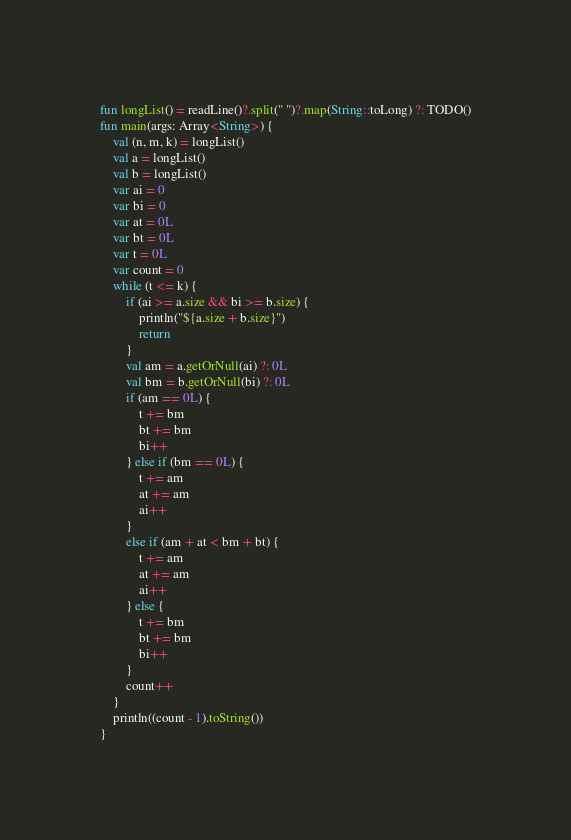Convert code to text. <code><loc_0><loc_0><loc_500><loc_500><_Kotlin_>fun longList() = readLine()?.split(" ")?.map(String::toLong) ?: TODO()
fun main(args: Array<String>) {
    val (n, m, k) = longList()
    val a = longList()
    val b = longList()
    var ai = 0
    var bi = 0
    var at = 0L
    var bt = 0L
    var t = 0L
    var count = 0
    while (t <= k) {
        if (ai >= a.size && bi >= b.size) {
            println("${a.size + b.size}")
            return
        }
        val am = a.getOrNull(ai) ?: 0L
        val bm = b.getOrNull(bi) ?: 0L
        if (am == 0L) {
            t += bm
            bt += bm
            bi++
        } else if (bm == 0L) {
            t += am
            at += am
            ai++
        }
        else if (am + at < bm + bt) {
            t += am
            at += am
            ai++
        } else {
            t += bm
            bt += bm
            bi++
        }
        count++
    }
    println((count - 1).toString())
}
</code> 